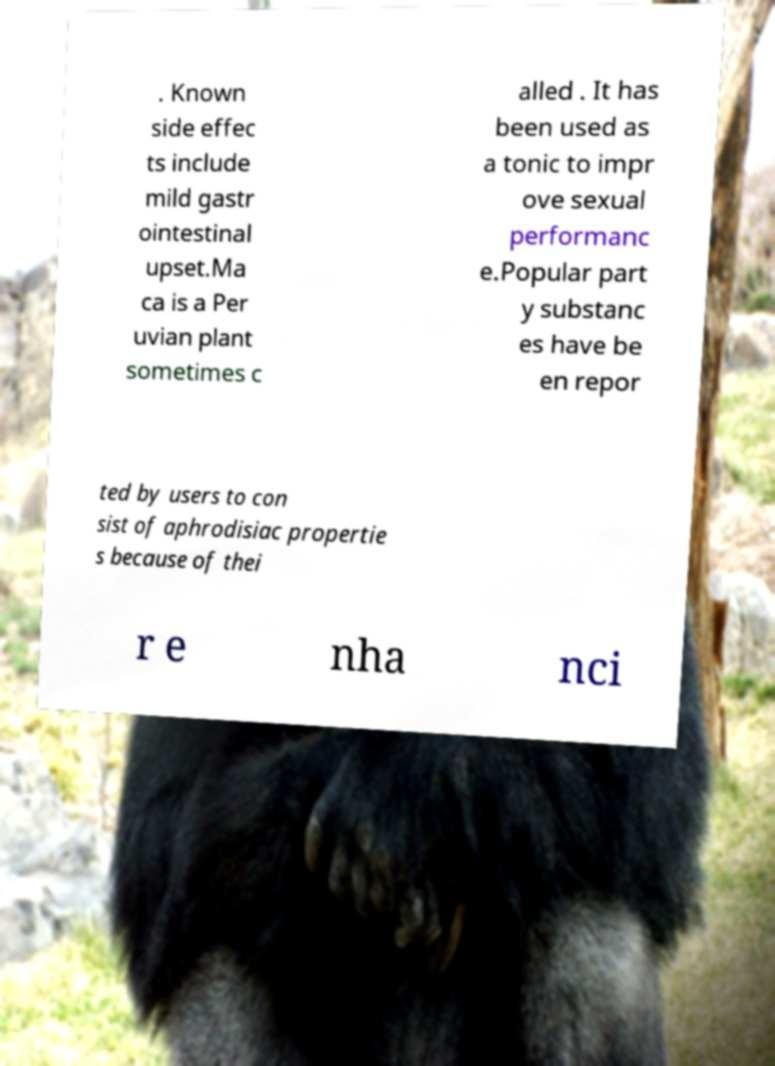For documentation purposes, I need the text within this image transcribed. Could you provide that? . Known side effec ts include mild gastr ointestinal upset.Ma ca is a Per uvian plant sometimes c alled . It has been used as a tonic to impr ove sexual performanc e.Popular part y substanc es have be en repor ted by users to con sist of aphrodisiac propertie s because of thei r e nha nci 